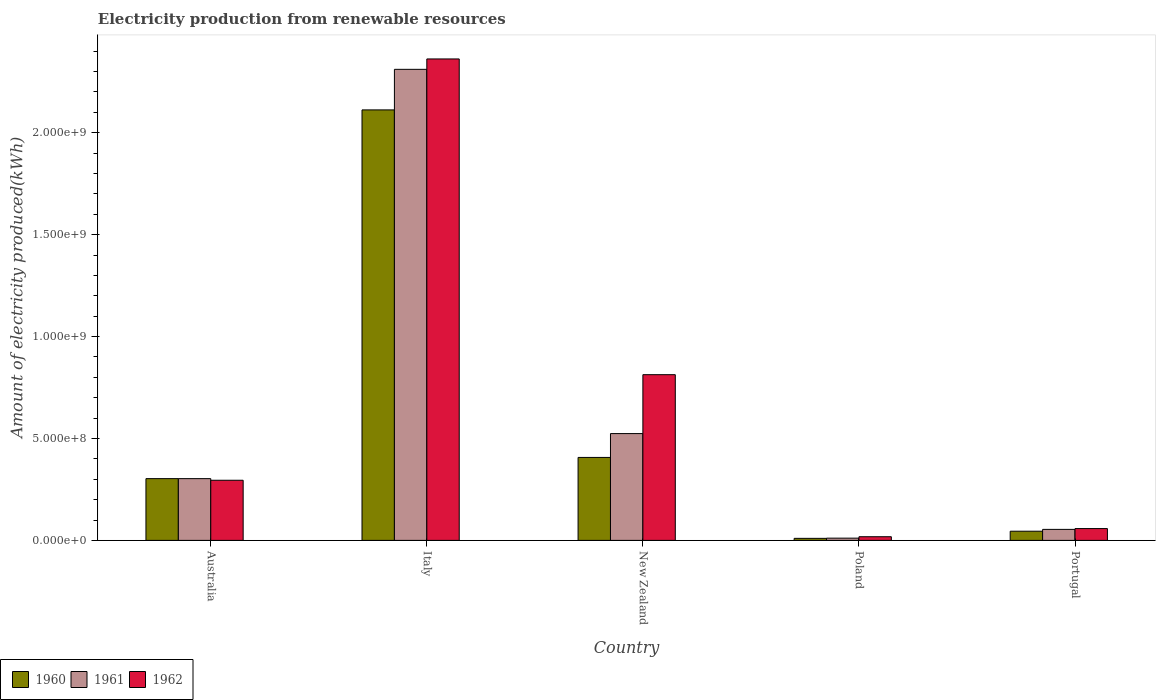Are the number of bars on each tick of the X-axis equal?
Your answer should be compact. Yes. What is the amount of electricity produced in 1961 in New Zealand?
Your answer should be compact. 5.24e+08. Across all countries, what is the maximum amount of electricity produced in 1961?
Your response must be concise. 2.31e+09. Across all countries, what is the minimum amount of electricity produced in 1962?
Offer a terse response. 1.80e+07. In which country was the amount of electricity produced in 1961 minimum?
Make the answer very short. Poland. What is the total amount of electricity produced in 1961 in the graph?
Keep it short and to the point. 3.20e+09. What is the difference between the amount of electricity produced in 1960 in Australia and that in Poland?
Give a very brief answer. 2.93e+08. What is the difference between the amount of electricity produced in 1961 in Poland and the amount of electricity produced in 1960 in Australia?
Provide a short and direct response. -2.92e+08. What is the average amount of electricity produced in 1961 per country?
Offer a very short reply. 6.41e+08. What is the difference between the amount of electricity produced of/in 1962 and amount of electricity produced of/in 1961 in Italy?
Ensure brevity in your answer.  5.10e+07. What is the ratio of the amount of electricity produced in 1960 in New Zealand to that in Poland?
Offer a terse response. 40.7. Is the amount of electricity produced in 1961 in Australia less than that in Italy?
Keep it short and to the point. Yes. What is the difference between the highest and the second highest amount of electricity produced in 1962?
Ensure brevity in your answer.  1.55e+09. What is the difference between the highest and the lowest amount of electricity produced in 1961?
Keep it short and to the point. 2.30e+09. In how many countries, is the amount of electricity produced in 1960 greater than the average amount of electricity produced in 1960 taken over all countries?
Provide a succinct answer. 1. Is the sum of the amount of electricity produced in 1960 in Italy and Portugal greater than the maximum amount of electricity produced in 1961 across all countries?
Your answer should be compact. No. What does the 3rd bar from the left in Poland represents?
Your answer should be compact. 1962. What does the 2nd bar from the right in Italy represents?
Offer a very short reply. 1961. Is it the case that in every country, the sum of the amount of electricity produced in 1961 and amount of electricity produced in 1962 is greater than the amount of electricity produced in 1960?
Keep it short and to the point. Yes. How many bars are there?
Offer a very short reply. 15. Are the values on the major ticks of Y-axis written in scientific E-notation?
Make the answer very short. Yes. Does the graph contain any zero values?
Your answer should be compact. No. Where does the legend appear in the graph?
Offer a terse response. Bottom left. What is the title of the graph?
Make the answer very short. Electricity production from renewable resources. Does "2015" appear as one of the legend labels in the graph?
Offer a terse response. No. What is the label or title of the X-axis?
Provide a short and direct response. Country. What is the label or title of the Y-axis?
Give a very brief answer. Amount of electricity produced(kWh). What is the Amount of electricity produced(kWh) in 1960 in Australia?
Provide a succinct answer. 3.03e+08. What is the Amount of electricity produced(kWh) of 1961 in Australia?
Your answer should be compact. 3.03e+08. What is the Amount of electricity produced(kWh) of 1962 in Australia?
Ensure brevity in your answer.  2.95e+08. What is the Amount of electricity produced(kWh) of 1960 in Italy?
Offer a very short reply. 2.11e+09. What is the Amount of electricity produced(kWh) of 1961 in Italy?
Provide a short and direct response. 2.31e+09. What is the Amount of electricity produced(kWh) of 1962 in Italy?
Ensure brevity in your answer.  2.36e+09. What is the Amount of electricity produced(kWh) in 1960 in New Zealand?
Ensure brevity in your answer.  4.07e+08. What is the Amount of electricity produced(kWh) in 1961 in New Zealand?
Provide a succinct answer. 5.24e+08. What is the Amount of electricity produced(kWh) of 1962 in New Zealand?
Give a very brief answer. 8.13e+08. What is the Amount of electricity produced(kWh) in 1960 in Poland?
Offer a very short reply. 1.00e+07. What is the Amount of electricity produced(kWh) in 1961 in Poland?
Offer a very short reply. 1.10e+07. What is the Amount of electricity produced(kWh) of 1962 in Poland?
Ensure brevity in your answer.  1.80e+07. What is the Amount of electricity produced(kWh) in 1960 in Portugal?
Provide a short and direct response. 4.50e+07. What is the Amount of electricity produced(kWh) in 1961 in Portugal?
Your response must be concise. 5.40e+07. What is the Amount of electricity produced(kWh) in 1962 in Portugal?
Your answer should be very brief. 5.80e+07. Across all countries, what is the maximum Amount of electricity produced(kWh) of 1960?
Ensure brevity in your answer.  2.11e+09. Across all countries, what is the maximum Amount of electricity produced(kWh) in 1961?
Give a very brief answer. 2.31e+09. Across all countries, what is the maximum Amount of electricity produced(kWh) of 1962?
Make the answer very short. 2.36e+09. Across all countries, what is the minimum Amount of electricity produced(kWh) of 1960?
Provide a succinct answer. 1.00e+07. Across all countries, what is the minimum Amount of electricity produced(kWh) in 1961?
Your answer should be very brief. 1.10e+07. Across all countries, what is the minimum Amount of electricity produced(kWh) in 1962?
Ensure brevity in your answer.  1.80e+07. What is the total Amount of electricity produced(kWh) of 1960 in the graph?
Provide a short and direct response. 2.88e+09. What is the total Amount of electricity produced(kWh) of 1961 in the graph?
Offer a very short reply. 3.20e+09. What is the total Amount of electricity produced(kWh) of 1962 in the graph?
Your answer should be very brief. 3.55e+09. What is the difference between the Amount of electricity produced(kWh) of 1960 in Australia and that in Italy?
Your response must be concise. -1.81e+09. What is the difference between the Amount of electricity produced(kWh) of 1961 in Australia and that in Italy?
Give a very brief answer. -2.01e+09. What is the difference between the Amount of electricity produced(kWh) in 1962 in Australia and that in Italy?
Your answer should be compact. -2.07e+09. What is the difference between the Amount of electricity produced(kWh) in 1960 in Australia and that in New Zealand?
Provide a short and direct response. -1.04e+08. What is the difference between the Amount of electricity produced(kWh) of 1961 in Australia and that in New Zealand?
Make the answer very short. -2.21e+08. What is the difference between the Amount of electricity produced(kWh) in 1962 in Australia and that in New Zealand?
Your answer should be very brief. -5.18e+08. What is the difference between the Amount of electricity produced(kWh) of 1960 in Australia and that in Poland?
Ensure brevity in your answer.  2.93e+08. What is the difference between the Amount of electricity produced(kWh) in 1961 in Australia and that in Poland?
Offer a very short reply. 2.92e+08. What is the difference between the Amount of electricity produced(kWh) in 1962 in Australia and that in Poland?
Your answer should be very brief. 2.77e+08. What is the difference between the Amount of electricity produced(kWh) of 1960 in Australia and that in Portugal?
Your answer should be compact. 2.58e+08. What is the difference between the Amount of electricity produced(kWh) of 1961 in Australia and that in Portugal?
Provide a short and direct response. 2.49e+08. What is the difference between the Amount of electricity produced(kWh) in 1962 in Australia and that in Portugal?
Give a very brief answer. 2.37e+08. What is the difference between the Amount of electricity produced(kWh) in 1960 in Italy and that in New Zealand?
Offer a terse response. 1.70e+09. What is the difference between the Amount of electricity produced(kWh) in 1961 in Italy and that in New Zealand?
Provide a short and direct response. 1.79e+09. What is the difference between the Amount of electricity produced(kWh) in 1962 in Italy and that in New Zealand?
Provide a short and direct response. 1.55e+09. What is the difference between the Amount of electricity produced(kWh) of 1960 in Italy and that in Poland?
Ensure brevity in your answer.  2.10e+09. What is the difference between the Amount of electricity produced(kWh) of 1961 in Italy and that in Poland?
Your answer should be compact. 2.30e+09. What is the difference between the Amount of electricity produced(kWh) of 1962 in Italy and that in Poland?
Make the answer very short. 2.34e+09. What is the difference between the Amount of electricity produced(kWh) of 1960 in Italy and that in Portugal?
Ensure brevity in your answer.  2.07e+09. What is the difference between the Amount of electricity produced(kWh) of 1961 in Italy and that in Portugal?
Make the answer very short. 2.26e+09. What is the difference between the Amount of electricity produced(kWh) of 1962 in Italy and that in Portugal?
Your answer should be compact. 2.30e+09. What is the difference between the Amount of electricity produced(kWh) in 1960 in New Zealand and that in Poland?
Your answer should be very brief. 3.97e+08. What is the difference between the Amount of electricity produced(kWh) in 1961 in New Zealand and that in Poland?
Give a very brief answer. 5.13e+08. What is the difference between the Amount of electricity produced(kWh) in 1962 in New Zealand and that in Poland?
Your answer should be very brief. 7.95e+08. What is the difference between the Amount of electricity produced(kWh) of 1960 in New Zealand and that in Portugal?
Offer a terse response. 3.62e+08. What is the difference between the Amount of electricity produced(kWh) of 1961 in New Zealand and that in Portugal?
Provide a short and direct response. 4.70e+08. What is the difference between the Amount of electricity produced(kWh) in 1962 in New Zealand and that in Portugal?
Make the answer very short. 7.55e+08. What is the difference between the Amount of electricity produced(kWh) of 1960 in Poland and that in Portugal?
Make the answer very short. -3.50e+07. What is the difference between the Amount of electricity produced(kWh) of 1961 in Poland and that in Portugal?
Offer a terse response. -4.30e+07. What is the difference between the Amount of electricity produced(kWh) of 1962 in Poland and that in Portugal?
Your response must be concise. -4.00e+07. What is the difference between the Amount of electricity produced(kWh) in 1960 in Australia and the Amount of electricity produced(kWh) in 1961 in Italy?
Provide a succinct answer. -2.01e+09. What is the difference between the Amount of electricity produced(kWh) of 1960 in Australia and the Amount of electricity produced(kWh) of 1962 in Italy?
Offer a terse response. -2.06e+09. What is the difference between the Amount of electricity produced(kWh) in 1961 in Australia and the Amount of electricity produced(kWh) in 1962 in Italy?
Give a very brief answer. -2.06e+09. What is the difference between the Amount of electricity produced(kWh) of 1960 in Australia and the Amount of electricity produced(kWh) of 1961 in New Zealand?
Provide a succinct answer. -2.21e+08. What is the difference between the Amount of electricity produced(kWh) in 1960 in Australia and the Amount of electricity produced(kWh) in 1962 in New Zealand?
Make the answer very short. -5.10e+08. What is the difference between the Amount of electricity produced(kWh) of 1961 in Australia and the Amount of electricity produced(kWh) of 1962 in New Zealand?
Your answer should be compact. -5.10e+08. What is the difference between the Amount of electricity produced(kWh) in 1960 in Australia and the Amount of electricity produced(kWh) in 1961 in Poland?
Your answer should be compact. 2.92e+08. What is the difference between the Amount of electricity produced(kWh) of 1960 in Australia and the Amount of electricity produced(kWh) of 1962 in Poland?
Give a very brief answer. 2.85e+08. What is the difference between the Amount of electricity produced(kWh) of 1961 in Australia and the Amount of electricity produced(kWh) of 1962 in Poland?
Offer a very short reply. 2.85e+08. What is the difference between the Amount of electricity produced(kWh) of 1960 in Australia and the Amount of electricity produced(kWh) of 1961 in Portugal?
Make the answer very short. 2.49e+08. What is the difference between the Amount of electricity produced(kWh) of 1960 in Australia and the Amount of electricity produced(kWh) of 1962 in Portugal?
Your answer should be compact. 2.45e+08. What is the difference between the Amount of electricity produced(kWh) of 1961 in Australia and the Amount of electricity produced(kWh) of 1962 in Portugal?
Your answer should be compact. 2.45e+08. What is the difference between the Amount of electricity produced(kWh) in 1960 in Italy and the Amount of electricity produced(kWh) in 1961 in New Zealand?
Keep it short and to the point. 1.59e+09. What is the difference between the Amount of electricity produced(kWh) of 1960 in Italy and the Amount of electricity produced(kWh) of 1962 in New Zealand?
Provide a succinct answer. 1.30e+09. What is the difference between the Amount of electricity produced(kWh) of 1961 in Italy and the Amount of electricity produced(kWh) of 1962 in New Zealand?
Offer a terse response. 1.50e+09. What is the difference between the Amount of electricity produced(kWh) in 1960 in Italy and the Amount of electricity produced(kWh) in 1961 in Poland?
Offer a very short reply. 2.10e+09. What is the difference between the Amount of electricity produced(kWh) in 1960 in Italy and the Amount of electricity produced(kWh) in 1962 in Poland?
Make the answer very short. 2.09e+09. What is the difference between the Amount of electricity produced(kWh) of 1961 in Italy and the Amount of electricity produced(kWh) of 1962 in Poland?
Make the answer very short. 2.29e+09. What is the difference between the Amount of electricity produced(kWh) of 1960 in Italy and the Amount of electricity produced(kWh) of 1961 in Portugal?
Ensure brevity in your answer.  2.06e+09. What is the difference between the Amount of electricity produced(kWh) in 1960 in Italy and the Amount of electricity produced(kWh) in 1962 in Portugal?
Offer a terse response. 2.05e+09. What is the difference between the Amount of electricity produced(kWh) of 1961 in Italy and the Amount of electricity produced(kWh) of 1962 in Portugal?
Make the answer very short. 2.25e+09. What is the difference between the Amount of electricity produced(kWh) in 1960 in New Zealand and the Amount of electricity produced(kWh) in 1961 in Poland?
Offer a terse response. 3.96e+08. What is the difference between the Amount of electricity produced(kWh) of 1960 in New Zealand and the Amount of electricity produced(kWh) of 1962 in Poland?
Give a very brief answer. 3.89e+08. What is the difference between the Amount of electricity produced(kWh) of 1961 in New Zealand and the Amount of electricity produced(kWh) of 1962 in Poland?
Your response must be concise. 5.06e+08. What is the difference between the Amount of electricity produced(kWh) of 1960 in New Zealand and the Amount of electricity produced(kWh) of 1961 in Portugal?
Make the answer very short. 3.53e+08. What is the difference between the Amount of electricity produced(kWh) of 1960 in New Zealand and the Amount of electricity produced(kWh) of 1962 in Portugal?
Give a very brief answer. 3.49e+08. What is the difference between the Amount of electricity produced(kWh) of 1961 in New Zealand and the Amount of electricity produced(kWh) of 1962 in Portugal?
Provide a succinct answer. 4.66e+08. What is the difference between the Amount of electricity produced(kWh) in 1960 in Poland and the Amount of electricity produced(kWh) in 1961 in Portugal?
Offer a very short reply. -4.40e+07. What is the difference between the Amount of electricity produced(kWh) of 1960 in Poland and the Amount of electricity produced(kWh) of 1962 in Portugal?
Provide a short and direct response. -4.80e+07. What is the difference between the Amount of electricity produced(kWh) of 1961 in Poland and the Amount of electricity produced(kWh) of 1962 in Portugal?
Give a very brief answer. -4.70e+07. What is the average Amount of electricity produced(kWh) of 1960 per country?
Keep it short and to the point. 5.75e+08. What is the average Amount of electricity produced(kWh) of 1961 per country?
Provide a short and direct response. 6.41e+08. What is the average Amount of electricity produced(kWh) in 1962 per country?
Offer a very short reply. 7.09e+08. What is the difference between the Amount of electricity produced(kWh) in 1960 and Amount of electricity produced(kWh) in 1961 in Australia?
Ensure brevity in your answer.  0. What is the difference between the Amount of electricity produced(kWh) in 1960 and Amount of electricity produced(kWh) in 1961 in Italy?
Your answer should be compact. -1.99e+08. What is the difference between the Amount of electricity produced(kWh) in 1960 and Amount of electricity produced(kWh) in 1962 in Italy?
Offer a very short reply. -2.50e+08. What is the difference between the Amount of electricity produced(kWh) of 1961 and Amount of electricity produced(kWh) of 1962 in Italy?
Your answer should be very brief. -5.10e+07. What is the difference between the Amount of electricity produced(kWh) of 1960 and Amount of electricity produced(kWh) of 1961 in New Zealand?
Your answer should be compact. -1.17e+08. What is the difference between the Amount of electricity produced(kWh) of 1960 and Amount of electricity produced(kWh) of 1962 in New Zealand?
Provide a succinct answer. -4.06e+08. What is the difference between the Amount of electricity produced(kWh) in 1961 and Amount of electricity produced(kWh) in 1962 in New Zealand?
Your response must be concise. -2.89e+08. What is the difference between the Amount of electricity produced(kWh) in 1960 and Amount of electricity produced(kWh) in 1962 in Poland?
Give a very brief answer. -8.00e+06. What is the difference between the Amount of electricity produced(kWh) in 1961 and Amount of electricity produced(kWh) in 1962 in Poland?
Provide a succinct answer. -7.00e+06. What is the difference between the Amount of electricity produced(kWh) in 1960 and Amount of electricity produced(kWh) in 1961 in Portugal?
Your answer should be compact. -9.00e+06. What is the difference between the Amount of electricity produced(kWh) of 1960 and Amount of electricity produced(kWh) of 1962 in Portugal?
Make the answer very short. -1.30e+07. What is the difference between the Amount of electricity produced(kWh) in 1961 and Amount of electricity produced(kWh) in 1962 in Portugal?
Ensure brevity in your answer.  -4.00e+06. What is the ratio of the Amount of electricity produced(kWh) in 1960 in Australia to that in Italy?
Make the answer very short. 0.14. What is the ratio of the Amount of electricity produced(kWh) in 1961 in Australia to that in Italy?
Your answer should be compact. 0.13. What is the ratio of the Amount of electricity produced(kWh) of 1962 in Australia to that in Italy?
Your answer should be compact. 0.12. What is the ratio of the Amount of electricity produced(kWh) of 1960 in Australia to that in New Zealand?
Keep it short and to the point. 0.74. What is the ratio of the Amount of electricity produced(kWh) in 1961 in Australia to that in New Zealand?
Ensure brevity in your answer.  0.58. What is the ratio of the Amount of electricity produced(kWh) in 1962 in Australia to that in New Zealand?
Your response must be concise. 0.36. What is the ratio of the Amount of electricity produced(kWh) of 1960 in Australia to that in Poland?
Keep it short and to the point. 30.3. What is the ratio of the Amount of electricity produced(kWh) of 1961 in Australia to that in Poland?
Offer a terse response. 27.55. What is the ratio of the Amount of electricity produced(kWh) of 1962 in Australia to that in Poland?
Your response must be concise. 16.39. What is the ratio of the Amount of electricity produced(kWh) in 1960 in Australia to that in Portugal?
Provide a succinct answer. 6.73. What is the ratio of the Amount of electricity produced(kWh) in 1961 in Australia to that in Portugal?
Provide a short and direct response. 5.61. What is the ratio of the Amount of electricity produced(kWh) in 1962 in Australia to that in Portugal?
Offer a terse response. 5.09. What is the ratio of the Amount of electricity produced(kWh) in 1960 in Italy to that in New Zealand?
Your answer should be compact. 5.19. What is the ratio of the Amount of electricity produced(kWh) of 1961 in Italy to that in New Zealand?
Keep it short and to the point. 4.41. What is the ratio of the Amount of electricity produced(kWh) of 1962 in Italy to that in New Zealand?
Keep it short and to the point. 2.91. What is the ratio of the Amount of electricity produced(kWh) in 1960 in Italy to that in Poland?
Provide a short and direct response. 211.2. What is the ratio of the Amount of electricity produced(kWh) of 1961 in Italy to that in Poland?
Your response must be concise. 210.09. What is the ratio of the Amount of electricity produced(kWh) of 1962 in Italy to that in Poland?
Ensure brevity in your answer.  131.22. What is the ratio of the Amount of electricity produced(kWh) of 1960 in Italy to that in Portugal?
Provide a succinct answer. 46.93. What is the ratio of the Amount of electricity produced(kWh) in 1961 in Italy to that in Portugal?
Your response must be concise. 42.8. What is the ratio of the Amount of electricity produced(kWh) in 1962 in Italy to that in Portugal?
Your answer should be compact. 40.72. What is the ratio of the Amount of electricity produced(kWh) in 1960 in New Zealand to that in Poland?
Ensure brevity in your answer.  40.7. What is the ratio of the Amount of electricity produced(kWh) in 1961 in New Zealand to that in Poland?
Your response must be concise. 47.64. What is the ratio of the Amount of electricity produced(kWh) of 1962 in New Zealand to that in Poland?
Provide a succinct answer. 45.17. What is the ratio of the Amount of electricity produced(kWh) in 1960 in New Zealand to that in Portugal?
Ensure brevity in your answer.  9.04. What is the ratio of the Amount of electricity produced(kWh) in 1961 in New Zealand to that in Portugal?
Your answer should be very brief. 9.7. What is the ratio of the Amount of electricity produced(kWh) of 1962 in New Zealand to that in Portugal?
Give a very brief answer. 14.02. What is the ratio of the Amount of electricity produced(kWh) of 1960 in Poland to that in Portugal?
Give a very brief answer. 0.22. What is the ratio of the Amount of electricity produced(kWh) in 1961 in Poland to that in Portugal?
Your answer should be very brief. 0.2. What is the ratio of the Amount of electricity produced(kWh) in 1962 in Poland to that in Portugal?
Offer a terse response. 0.31. What is the difference between the highest and the second highest Amount of electricity produced(kWh) in 1960?
Offer a terse response. 1.70e+09. What is the difference between the highest and the second highest Amount of electricity produced(kWh) in 1961?
Offer a terse response. 1.79e+09. What is the difference between the highest and the second highest Amount of electricity produced(kWh) of 1962?
Offer a terse response. 1.55e+09. What is the difference between the highest and the lowest Amount of electricity produced(kWh) in 1960?
Your response must be concise. 2.10e+09. What is the difference between the highest and the lowest Amount of electricity produced(kWh) in 1961?
Ensure brevity in your answer.  2.30e+09. What is the difference between the highest and the lowest Amount of electricity produced(kWh) in 1962?
Keep it short and to the point. 2.34e+09. 